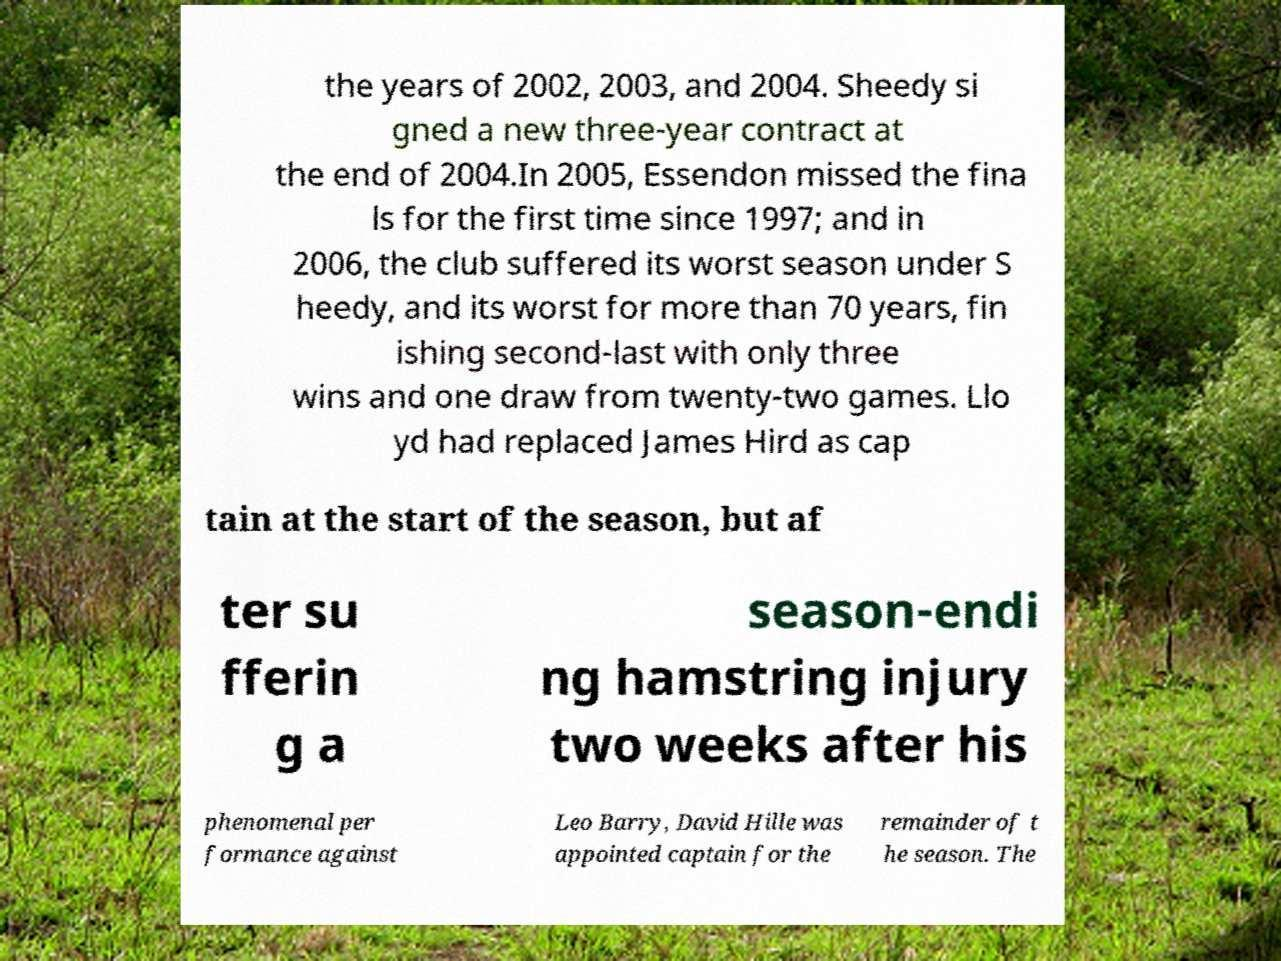There's text embedded in this image that I need extracted. Can you transcribe it verbatim? the years of 2002, 2003, and 2004. Sheedy si gned a new three-year contract at the end of 2004.In 2005, Essendon missed the fina ls for the first time since 1997; and in 2006, the club suffered its worst season under S heedy, and its worst for more than 70 years, fin ishing second-last with only three wins and one draw from twenty-two games. Llo yd had replaced James Hird as cap tain at the start of the season, but af ter su fferin g a season-endi ng hamstring injury two weeks after his phenomenal per formance against Leo Barry, David Hille was appointed captain for the remainder of t he season. The 